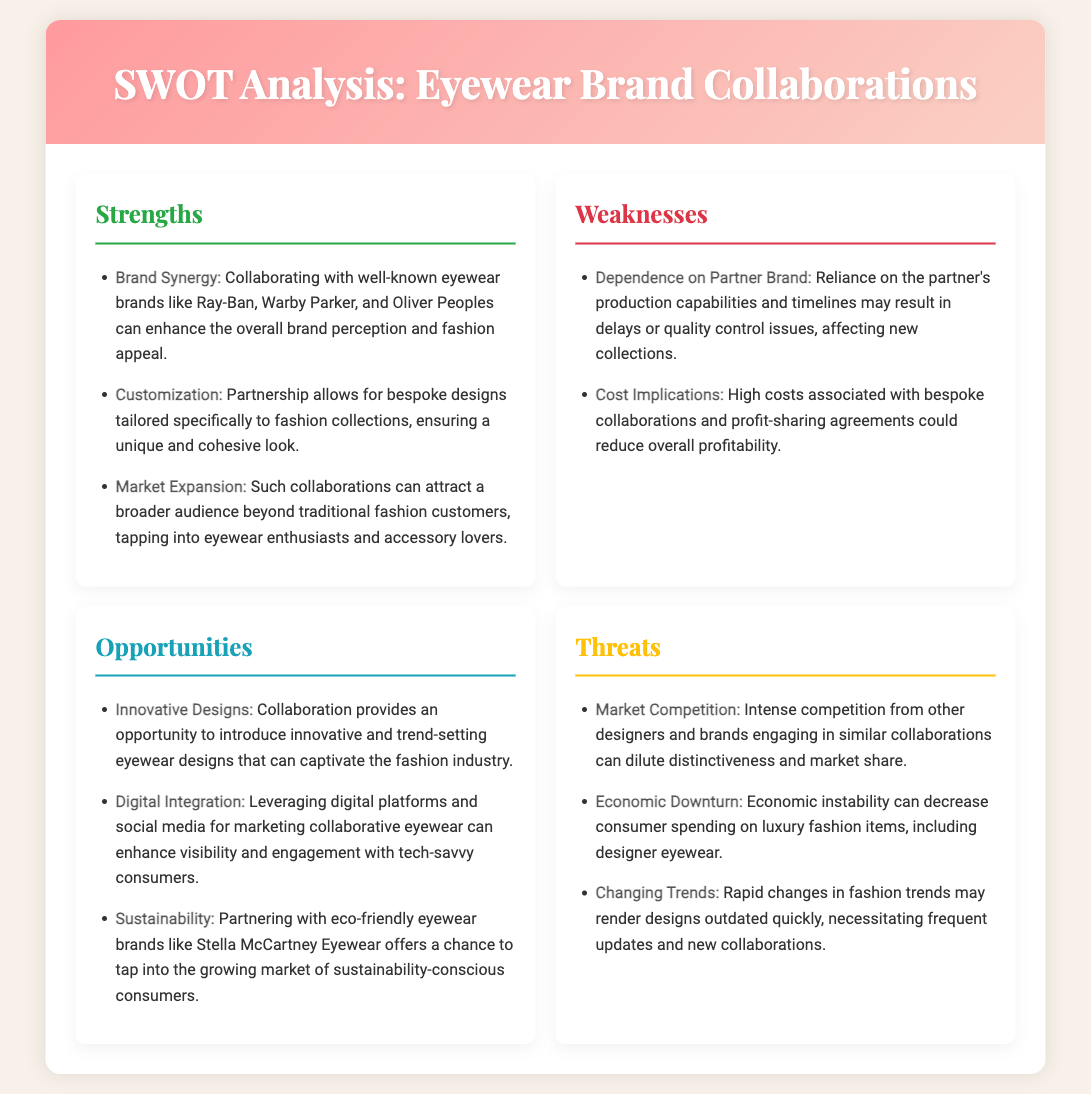what is one strength of collaborating with eyewear brands? The document lists several strengths, and one of them is "Brand Synergy," which enhances brand perception and fashion appeal.
Answer: Brand Synergy what does the weakness "Dependence on Partner Brand" refer to? This weakness points to reliance on the partner’s production capabilities and timelines, which may affect new collections.
Answer: Dependence on Partner Brand how many opportunities are listed in the document? The document enumerates three specific opportunities within the collaboration context.
Answer: 3 which eyewear brand is mentioned as an example of a sustainable partner? The document specifically mentions "Stella McCartney Eyewear" as an eco-friendly brand that could be partnered with.
Answer: Stella McCartney Eyewear what threat is associated with economic conditions according to the document? The document highlights "Economic Downturn" as a threat that can decrease consumer spending on luxury items.
Answer: Economic Downturn what does the opportunity for "Digital Integration" pertain to? This opportunity involves leveraging digital platforms and social media for marketing collaborative eyewear to enhance visibility and engagement.
Answer: Digital platforms and social media what aspect is highlighted as a potential cost-related issue under weaknesses? The document mentions "Cost Implications" related to high costs associated with bespoke collaborations.
Answer: Cost Implications 